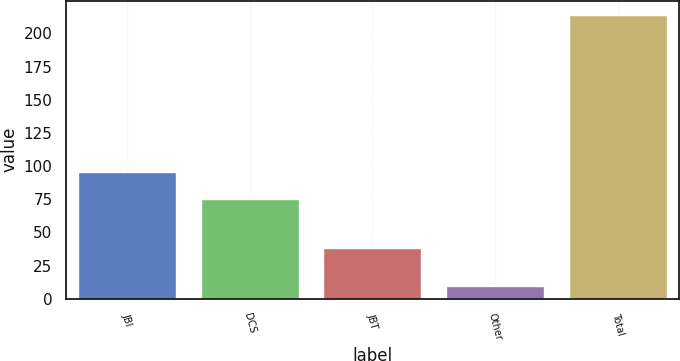Convert chart. <chart><loc_0><loc_0><loc_500><loc_500><bar_chart><fcel>JBI<fcel>DCS<fcel>JBT<fcel>Other<fcel>Total<nl><fcel>95.4<fcel>75<fcel>38<fcel>10<fcel>214<nl></chart> 